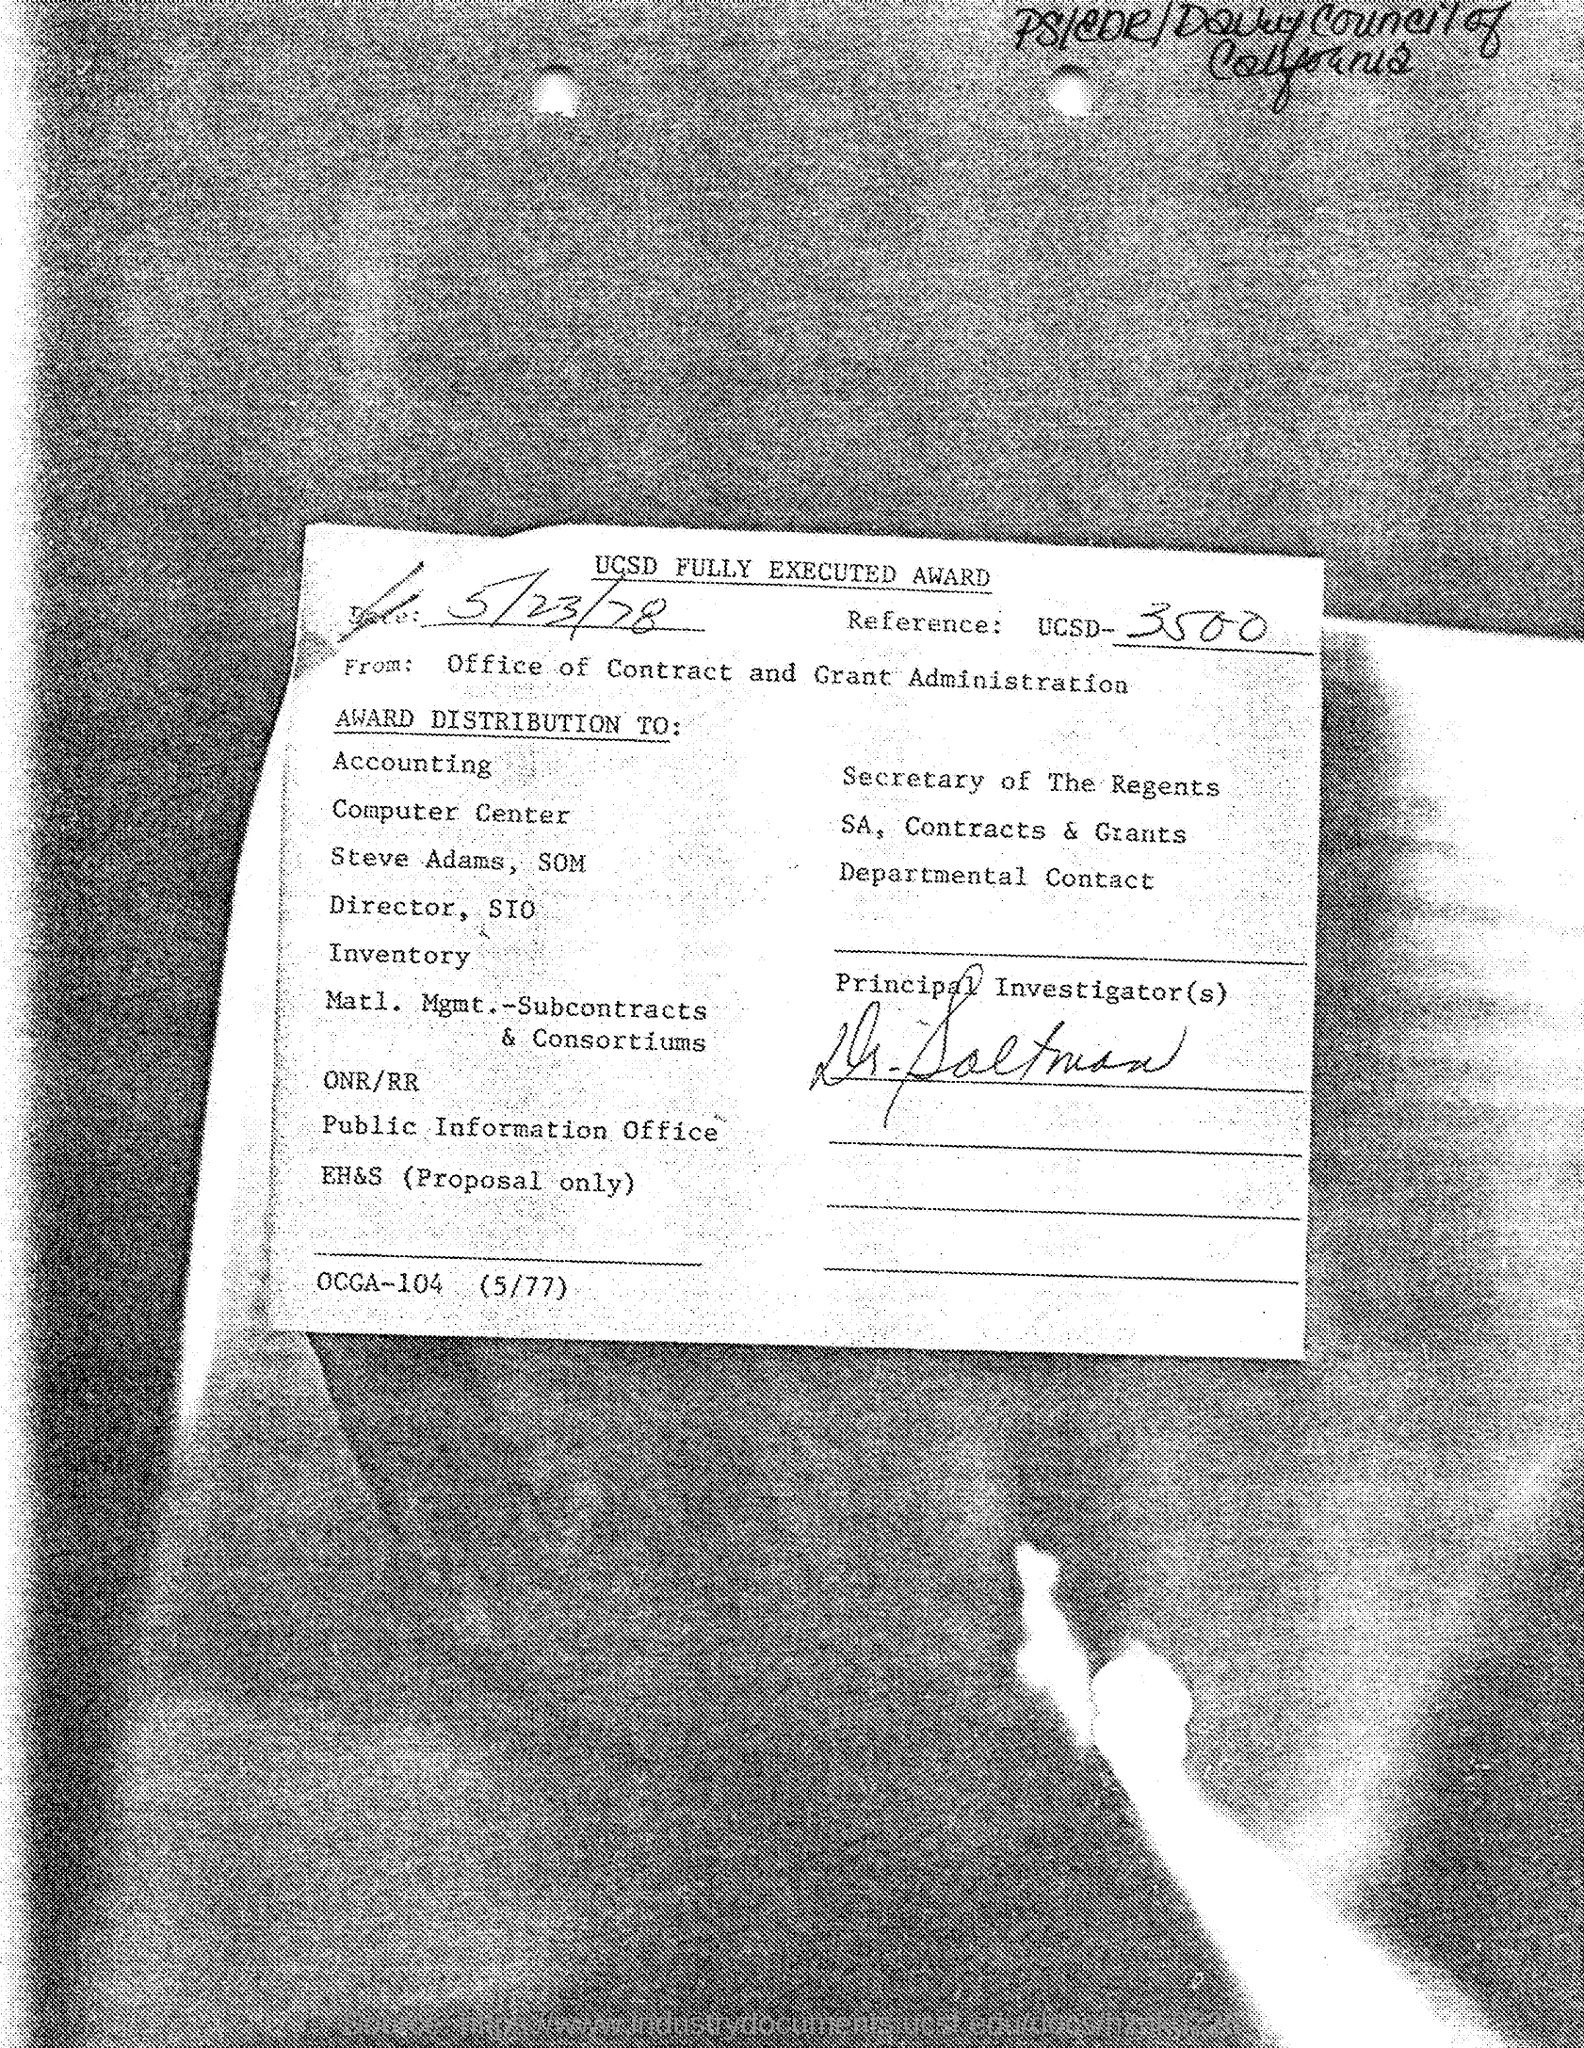What is the Title of the Document?
Provide a short and direct response. UCSD FULLY EXECUTED AWARD. What is the Date?
Ensure brevity in your answer.  5/23/78. 